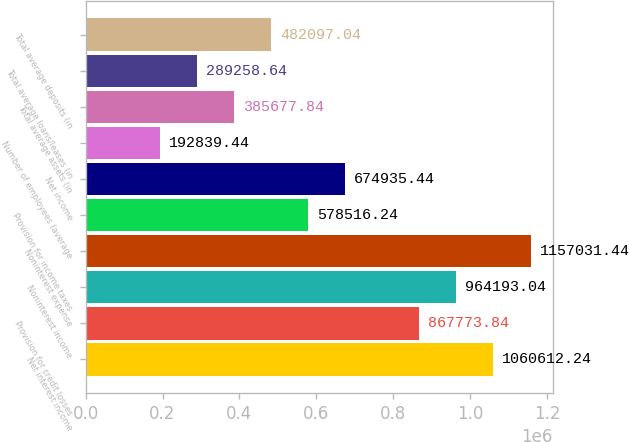Convert chart to OTSL. <chart><loc_0><loc_0><loc_500><loc_500><bar_chart><fcel>Net interest income<fcel>Provision for credit losses<fcel>Noninterest income<fcel>Noninterest expense<fcel>Provision for income taxes<fcel>Net income<fcel>Number of employees (average<fcel>Total average assets (in<fcel>Total average loans/leases (in<fcel>Total average deposits (in<nl><fcel>1.06061e+06<fcel>867774<fcel>964193<fcel>1.15703e+06<fcel>578516<fcel>674935<fcel>192839<fcel>385678<fcel>289259<fcel>482097<nl></chart> 